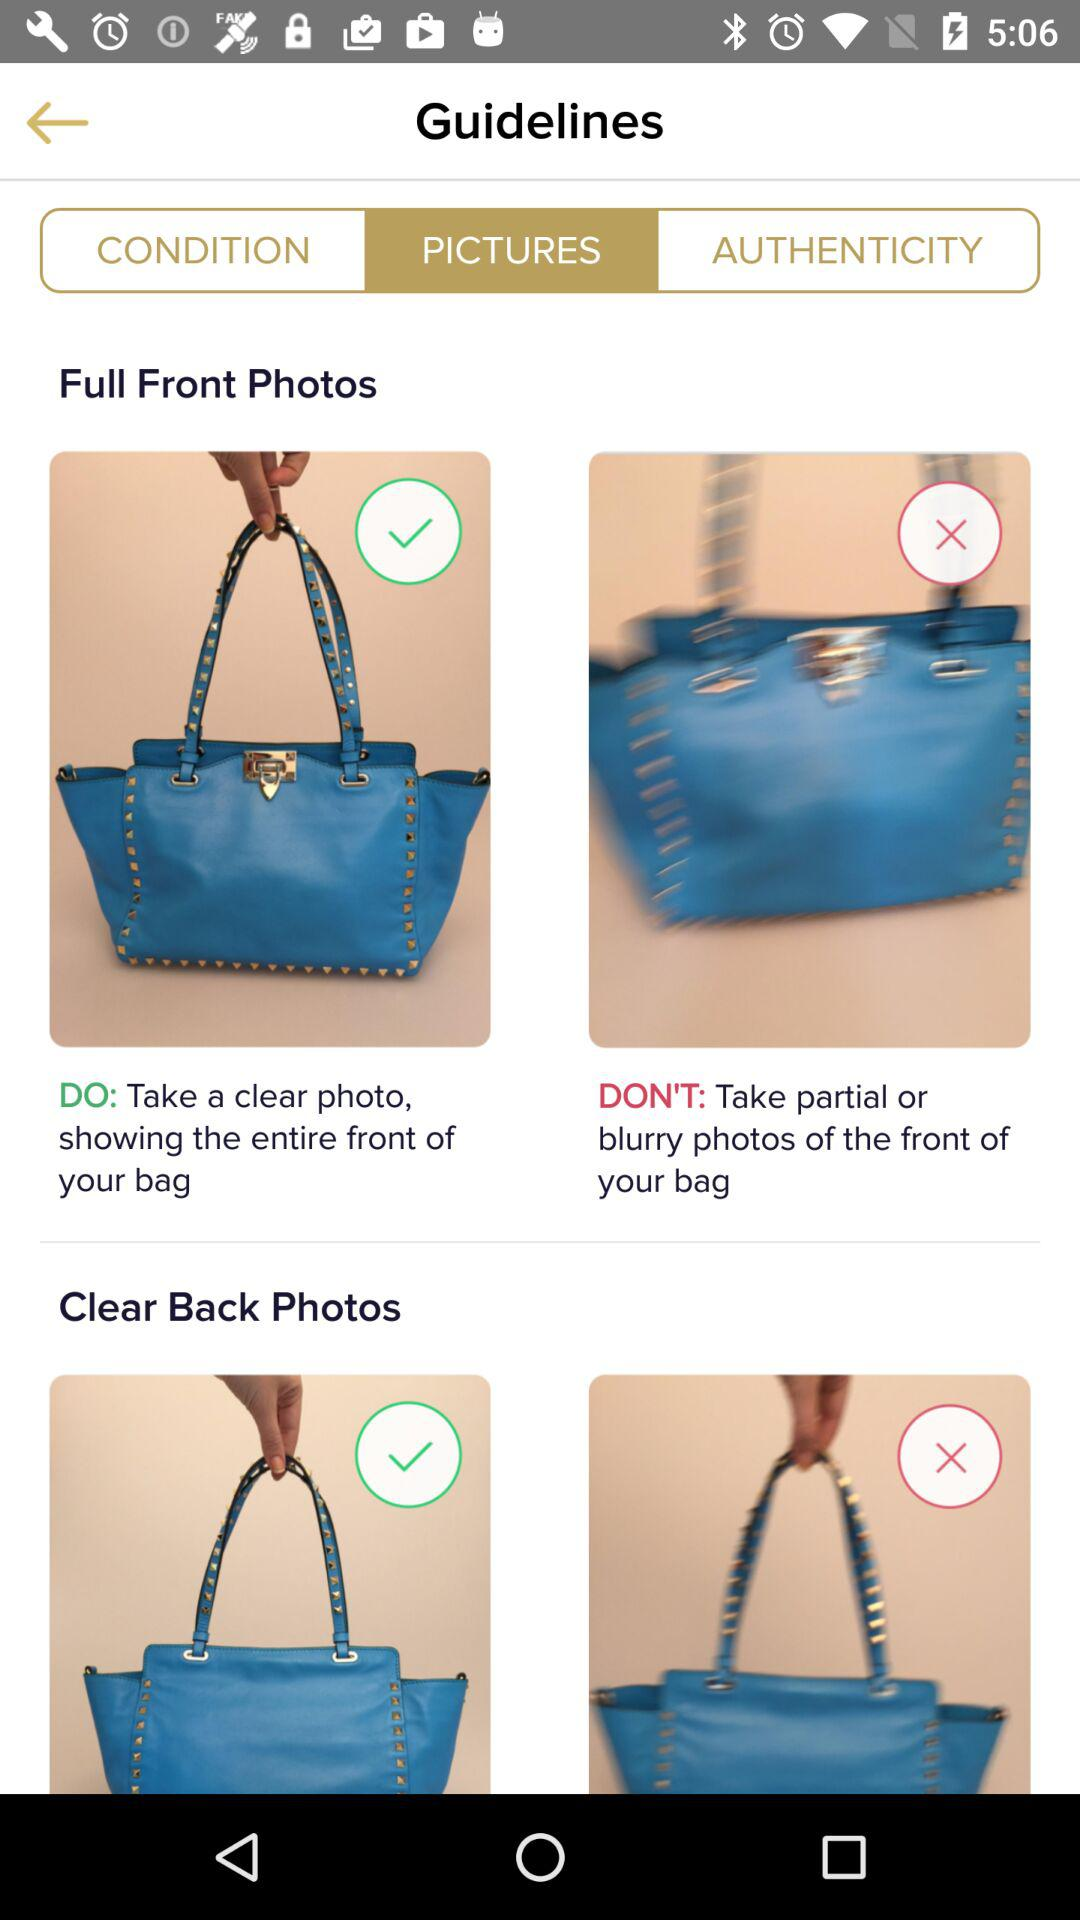Which option is selected? The selected option is "PICTURES". 